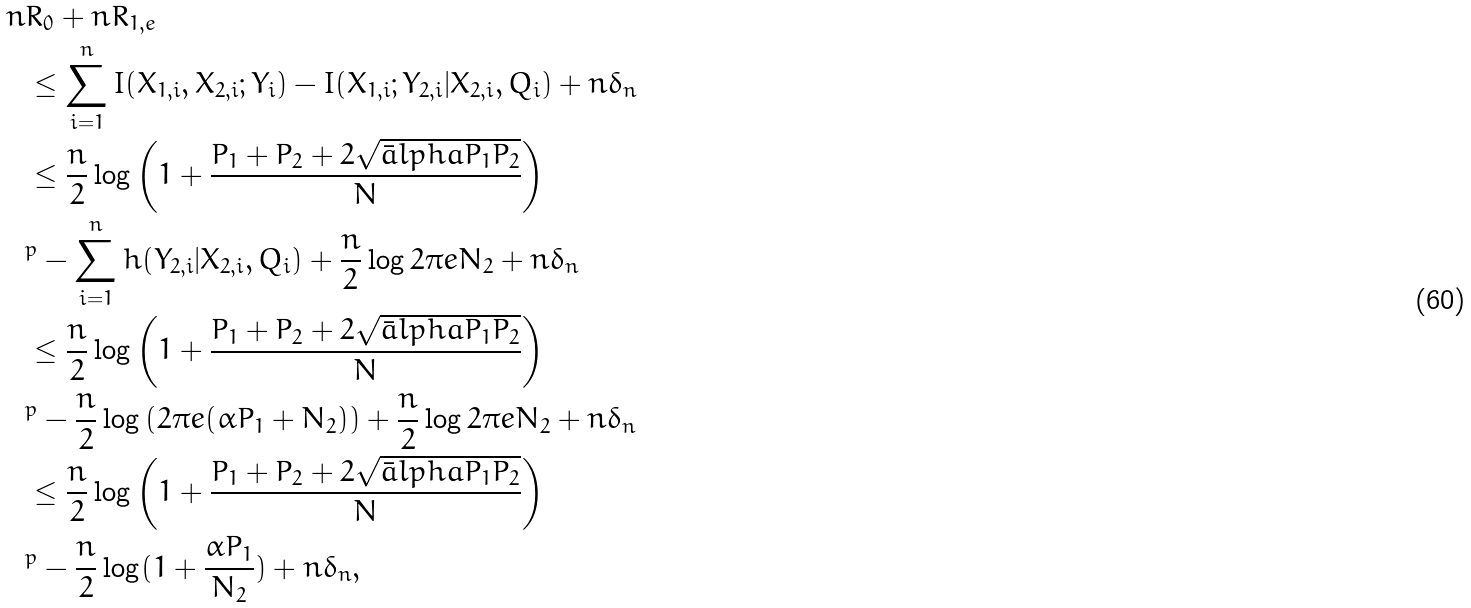Convert formula to latex. <formula><loc_0><loc_0><loc_500><loc_500>n & R _ { 0 } + n R _ { 1 , e } \\ & \leq \sum _ { i = 1 } ^ { n } I ( X _ { 1 , i } , X _ { 2 , i } ; Y _ { i } ) - I ( X _ { 1 , i } ; Y _ { 2 , i } | X _ { 2 , i } , Q _ { i } ) + n \delta _ { n } \\ & \leq \frac { n } { 2 } \log \left ( 1 + \frac { P _ { 1 } + P _ { 2 } + 2 \sqrt { \bar { a } l p h a P _ { 1 } P _ { 2 } } } { N } \right ) \\ & ^ { p } - \sum _ { i = 1 } ^ { n } h ( Y _ { 2 , i } | X _ { 2 , i } , Q _ { i } ) + \frac { n } { 2 } \log 2 \pi e N _ { 2 } + n \delta _ { n } \\ & \leq \frac { n } { 2 } \log \left ( 1 + \frac { P _ { 1 } + P _ { 2 } + 2 \sqrt { \bar { a } l p h a P _ { 1 } P _ { 2 } } } { N } \right ) \\ & ^ { p } - \frac { n } { 2 } \log \left ( 2 \pi e ( \alpha P _ { 1 } + N _ { 2 } ) \right ) + \frac { n } { 2 } \log 2 \pi e N _ { 2 } + n \delta _ { n } \\ & \leq \frac { n } { 2 } \log \left ( 1 + \frac { P _ { 1 } + P _ { 2 } + 2 \sqrt { \bar { a } l p h a P _ { 1 } P _ { 2 } } } { N } \right ) \\ & ^ { p } - \frac { n } { 2 } \log ( 1 + \frac { \alpha P _ { 1 } } { N _ { 2 } } ) + n \delta _ { n } ,</formula> 